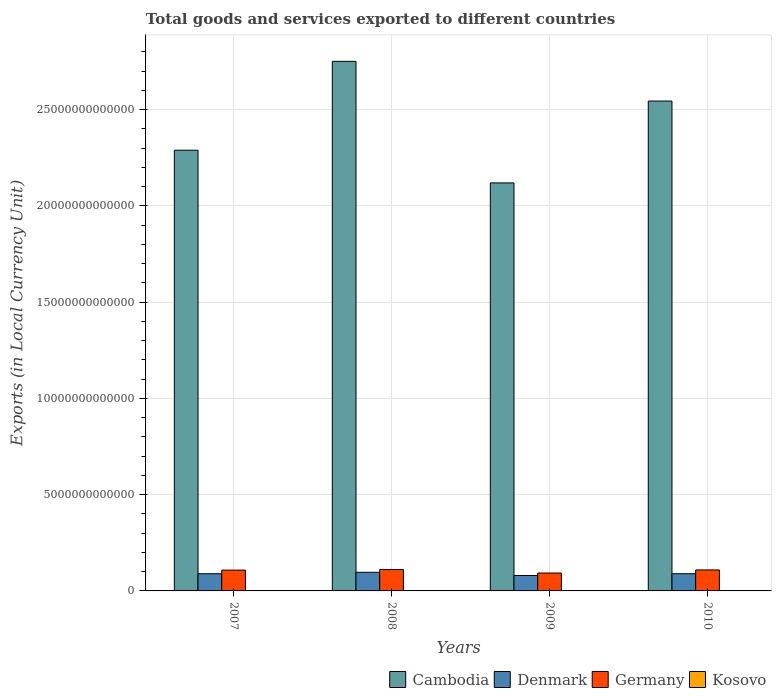How many different coloured bars are there?
Make the answer very short. 4. Are the number of bars per tick equal to the number of legend labels?
Ensure brevity in your answer.  Yes. Are the number of bars on each tick of the X-axis equal?
Offer a very short reply. Yes. How many bars are there on the 4th tick from the right?
Provide a succinct answer. 4. What is the label of the 2nd group of bars from the left?
Provide a short and direct response. 2008. What is the Amount of goods and services exports in Denmark in 2009?
Provide a short and direct response. 8.01e+11. Across all years, what is the maximum Amount of goods and services exports in Denmark?
Give a very brief answer. 9.68e+11. Across all years, what is the minimum Amount of goods and services exports in Denmark?
Ensure brevity in your answer.  8.01e+11. What is the total Amount of goods and services exports in Germany in the graph?
Make the answer very short. 4.21e+12. What is the difference between the Amount of goods and services exports in Cambodia in 2008 and that in 2009?
Keep it short and to the point. 6.31e+12. What is the difference between the Amount of goods and services exports in Cambodia in 2008 and the Amount of goods and services exports in Denmark in 2010?
Ensure brevity in your answer.  2.66e+13. What is the average Amount of goods and services exports in Denmark per year?
Make the answer very short. 8.89e+11. In the year 2008, what is the difference between the Amount of goods and services exports in Denmark and Amount of goods and services exports in Cambodia?
Provide a short and direct response. -2.65e+13. In how many years, is the Amount of goods and services exports in Cambodia greater than 4000000000000 LCU?
Offer a terse response. 4. What is the ratio of the Amount of goods and services exports in Denmark in 2009 to that in 2010?
Your answer should be compact. 0.9. Is the difference between the Amount of goods and services exports in Denmark in 2007 and 2008 greater than the difference between the Amount of goods and services exports in Cambodia in 2007 and 2008?
Give a very brief answer. Yes. What is the difference between the highest and the second highest Amount of goods and services exports in Kosovo?
Your response must be concise. 1.79e+08. What is the difference between the highest and the lowest Amount of goods and services exports in Germany?
Offer a very short reply. 1.83e+11. In how many years, is the Amount of goods and services exports in Denmark greater than the average Amount of goods and services exports in Denmark taken over all years?
Ensure brevity in your answer.  3. Is the sum of the Amount of goods and services exports in Denmark in 2008 and 2010 greater than the maximum Amount of goods and services exports in Germany across all years?
Give a very brief answer. Yes. What does the 1st bar from the left in 2008 represents?
Offer a very short reply. Cambodia. How many bars are there?
Ensure brevity in your answer.  16. How many years are there in the graph?
Make the answer very short. 4. What is the difference between two consecutive major ticks on the Y-axis?
Offer a very short reply. 5.00e+12. Are the values on the major ticks of Y-axis written in scientific E-notation?
Your response must be concise. No. Does the graph contain grids?
Your response must be concise. Yes. How are the legend labels stacked?
Make the answer very short. Horizontal. What is the title of the graph?
Your answer should be compact. Total goods and services exported to different countries. Does "Singapore" appear as one of the legend labels in the graph?
Offer a very short reply. No. What is the label or title of the X-axis?
Keep it short and to the point. Years. What is the label or title of the Y-axis?
Provide a succinct answer. Exports (in Local Currency Unit). What is the Exports (in Local Currency Unit) in Cambodia in 2007?
Provide a short and direct response. 2.29e+13. What is the Exports (in Local Currency Unit) of Denmark in 2007?
Provide a short and direct response. 8.93e+11. What is the Exports (in Local Currency Unit) in Germany in 2007?
Ensure brevity in your answer.  1.08e+12. What is the Exports (in Local Currency Unit) in Kosovo in 2007?
Offer a very short reply. 5.47e+08. What is the Exports (in Local Currency Unit) of Cambodia in 2008?
Provide a short and direct response. 2.75e+13. What is the Exports (in Local Currency Unit) of Denmark in 2008?
Offer a very short reply. 9.68e+11. What is the Exports (in Local Currency Unit) in Germany in 2008?
Ensure brevity in your answer.  1.11e+12. What is the Exports (in Local Currency Unit) in Kosovo in 2008?
Ensure brevity in your answer.  6.08e+08. What is the Exports (in Local Currency Unit) of Cambodia in 2009?
Offer a very short reply. 2.12e+13. What is the Exports (in Local Currency Unit) in Denmark in 2009?
Provide a short and direct response. 8.01e+11. What is the Exports (in Local Currency Unit) in Germany in 2009?
Provide a short and direct response. 9.30e+11. What is the Exports (in Local Currency Unit) in Kosovo in 2009?
Offer a very short reply. 6.94e+08. What is the Exports (in Local Currency Unit) in Cambodia in 2010?
Ensure brevity in your answer.  2.54e+13. What is the Exports (in Local Currency Unit) of Denmark in 2010?
Ensure brevity in your answer.  8.94e+11. What is the Exports (in Local Currency Unit) in Germany in 2010?
Your answer should be compact. 1.09e+12. What is the Exports (in Local Currency Unit) of Kosovo in 2010?
Provide a succinct answer. 8.74e+08. Across all years, what is the maximum Exports (in Local Currency Unit) of Cambodia?
Keep it short and to the point. 2.75e+13. Across all years, what is the maximum Exports (in Local Currency Unit) in Denmark?
Your answer should be very brief. 9.68e+11. Across all years, what is the maximum Exports (in Local Currency Unit) in Germany?
Offer a very short reply. 1.11e+12. Across all years, what is the maximum Exports (in Local Currency Unit) of Kosovo?
Offer a very short reply. 8.74e+08. Across all years, what is the minimum Exports (in Local Currency Unit) of Cambodia?
Your answer should be compact. 2.12e+13. Across all years, what is the minimum Exports (in Local Currency Unit) in Denmark?
Ensure brevity in your answer.  8.01e+11. Across all years, what is the minimum Exports (in Local Currency Unit) in Germany?
Your answer should be compact. 9.30e+11. Across all years, what is the minimum Exports (in Local Currency Unit) of Kosovo?
Your answer should be compact. 5.47e+08. What is the total Exports (in Local Currency Unit) in Cambodia in the graph?
Your answer should be compact. 9.70e+13. What is the total Exports (in Local Currency Unit) of Denmark in the graph?
Make the answer very short. 3.56e+12. What is the total Exports (in Local Currency Unit) of Germany in the graph?
Keep it short and to the point. 4.21e+12. What is the total Exports (in Local Currency Unit) of Kosovo in the graph?
Provide a succinct answer. 2.72e+09. What is the difference between the Exports (in Local Currency Unit) of Cambodia in 2007 and that in 2008?
Give a very brief answer. -4.62e+12. What is the difference between the Exports (in Local Currency Unit) in Denmark in 2007 and that in 2008?
Your response must be concise. -7.51e+1. What is the difference between the Exports (in Local Currency Unit) in Germany in 2007 and that in 2008?
Provide a succinct answer. -3.24e+1. What is the difference between the Exports (in Local Currency Unit) of Kosovo in 2007 and that in 2008?
Your answer should be compact. -6.15e+07. What is the difference between the Exports (in Local Currency Unit) in Cambodia in 2007 and that in 2009?
Offer a terse response. 1.70e+12. What is the difference between the Exports (in Local Currency Unit) of Denmark in 2007 and that in 2009?
Offer a very short reply. 9.20e+1. What is the difference between the Exports (in Local Currency Unit) of Germany in 2007 and that in 2009?
Make the answer very short. 1.51e+11. What is the difference between the Exports (in Local Currency Unit) of Kosovo in 2007 and that in 2009?
Make the answer very short. -1.48e+08. What is the difference between the Exports (in Local Currency Unit) of Cambodia in 2007 and that in 2010?
Ensure brevity in your answer.  -2.55e+12. What is the difference between the Exports (in Local Currency Unit) in Denmark in 2007 and that in 2010?
Provide a short and direct response. -1.41e+09. What is the difference between the Exports (in Local Currency Unit) of Germany in 2007 and that in 2010?
Provide a short and direct response. -9.15e+09. What is the difference between the Exports (in Local Currency Unit) of Kosovo in 2007 and that in 2010?
Offer a very short reply. -3.27e+08. What is the difference between the Exports (in Local Currency Unit) of Cambodia in 2008 and that in 2009?
Your response must be concise. 6.31e+12. What is the difference between the Exports (in Local Currency Unit) in Denmark in 2008 and that in 2009?
Provide a succinct answer. 1.67e+11. What is the difference between the Exports (in Local Currency Unit) of Germany in 2008 and that in 2009?
Make the answer very short. 1.83e+11. What is the difference between the Exports (in Local Currency Unit) in Kosovo in 2008 and that in 2009?
Give a very brief answer. -8.61e+07. What is the difference between the Exports (in Local Currency Unit) of Cambodia in 2008 and that in 2010?
Ensure brevity in your answer.  2.06e+12. What is the difference between the Exports (in Local Currency Unit) in Denmark in 2008 and that in 2010?
Keep it short and to the point. 7.37e+1. What is the difference between the Exports (in Local Currency Unit) in Germany in 2008 and that in 2010?
Offer a terse response. 2.32e+1. What is the difference between the Exports (in Local Currency Unit) in Kosovo in 2008 and that in 2010?
Your answer should be very brief. -2.65e+08. What is the difference between the Exports (in Local Currency Unit) in Cambodia in 2009 and that in 2010?
Your answer should be very brief. -4.25e+12. What is the difference between the Exports (in Local Currency Unit) of Denmark in 2009 and that in 2010?
Your response must be concise. -9.35e+1. What is the difference between the Exports (in Local Currency Unit) in Germany in 2009 and that in 2010?
Keep it short and to the point. -1.60e+11. What is the difference between the Exports (in Local Currency Unit) of Kosovo in 2009 and that in 2010?
Your answer should be compact. -1.79e+08. What is the difference between the Exports (in Local Currency Unit) of Cambodia in 2007 and the Exports (in Local Currency Unit) of Denmark in 2008?
Provide a short and direct response. 2.19e+13. What is the difference between the Exports (in Local Currency Unit) of Cambodia in 2007 and the Exports (in Local Currency Unit) of Germany in 2008?
Keep it short and to the point. 2.18e+13. What is the difference between the Exports (in Local Currency Unit) of Cambodia in 2007 and the Exports (in Local Currency Unit) of Kosovo in 2008?
Your answer should be very brief. 2.29e+13. What is the difference between the Exports (in Local Currency Unit) in Denmark in 2007 and the Exports (in Local Currency Unit) in Germany in 2008?
Keep it short and to the point. -2.20e+11. What is the difference between the Exports (in Local Currency Unit) of Denmark in 2007 and the Exports (in Local Currency Unit) of Kosovo in 2008?
Your answer should be very brief. 8.92e+11. What is the difference between the Exports (in Local Currency Unit) in Germany in 2007 and the Exports (in Local Currency Unit) in Kosovo in 2008?
Keep it short and to the point. 1.08e+12. What is the difference between the Exports (in Local Currency Unit) in Cambodia in 2007 and the Exports (in Local Currency Unit) in Denmark in 2009?
Provide a short and direct response. 2.21e+13. What is the difference between the Exports (in Local Currency Unit) of Cambodia in 2007 and the Exports (in Local Currency Unit) of Germany in 2009?
Keep it short and to the point. 2.20e+13. What is the difference between the Exports (in Local Currency Unit) in Cambodia in 2007 and the Exports (in Local Currency Unit) in Kosovo in 2009?
Keep it short and to the point. 2.29e+13. What is the difference between the Exports (in Local Currency Unit) in Denmark in 2007 and the Exports (in Local Currency Unit) in Germany in 2009?
Ensure brevity in your answer.  -3.72e+1. What is the difference between the Exports (in Local Currency Unit) in Denmark in 2007 and the Exports (in Local Currency Unit) in Kosovo in 2009?
Your answer should be compact. 8.92e+11. What is the difference between the Exports (in Local Currency Unit) in Germany in 2007 and the Exports (in Local Currency Unit) in Kosovo in 2009?
Your answer should be compact. 1.08e+12. What is the difference between the Exports (in Local Currency Unit) in Cambodia in 2007 and the Exports (in Local Currency Unit) in Denmark in 2010?
Give a very brief answer. 2.20e+13. What is the difference between the Exports (in Local Currency Unit) in Cambodia in 2007 and the Exports (in Local Currency Unit) in Germany in 2010?
Provide a short and direct response. 2.18e+13. What is the difference between the Exports (in Local Currency Unit) in Cambodia in 2007 and the Exports (in Local Currency Unit) in Kosovo in 2010?
Offer a terse response. 2.29e+13. What is the difference between the Exports (in Local Currency Unit) in Denmark in 2007 and the Exports (in Local Currency Unit) in Germany in 2010?
Keep it short and to the point. -1.97e+11. What is the difference between the Exports (in Local Currency Unit) in Denmark in 2007 and the Exports (in Local Currency Unit) in Kosovo in 2010?
Your answer should be very brief. 8.92e+11. What is the difference between the Exports (in Local Currency Unit) of Germany in 2007 and the Exports (in Local Currency Unit) of Kosovo in 2010?
Your answer should be compact. 1.08e+12. What is the difference between the Exports (in Local Currency Unit) of Cambodia in 2008 and the Exports (in Local Currency Unit) of Denmark in 2009?
Your answer should be compact. 2.67e+13. What is the difference between the Exports (in Local Currency Unit) of Cambodia in 2008 and the Exports (in Local Currency Unit) of Germany in 2009?
Offer a terse response. 2.66e+13. What is the difference between the Exports (in Local Currency Unit) in Cambodia in 2008 and the Exports (in Local Currency Unit) in Kosovo in 2009?
Your answer should be compact. 2.75e+13. What is the difference between the Exports (in Local Currency Unit) of Denmark in 2008 and the Exports (in Local Currency Unit) of Germany in 2009?
Provide a short and direct response. 3.79e+1. What is the difference between the Exports (in Local Currency Unit) in Denmark in 2008 and the Exports (in Local Currency Unit) in Kosovo in 2009?
Your answer should be compact. 9.67e+11. What is the difference between the Exports (in Local Currency Unit) in Germany in 2008 and the Exports (in Local Currency Unit) in Kosovo in 2009?
Your response must be concise. 1.11e+12. What is the difference between the Exports (in Local Currency Unit) of Cambodia in 2008 and the Exports (in Local Currency Unit) of Denmark in 2010?
Make the answer very short. 2.66e+13. What is the difference between the Exports (in Local Currency Unit) of Cambodia in 2008 and the Exports (in Local Currency Unit) of Germany in 2010?
Your response must be concise. 2.64e+13. What is the difference between the Exports (in Local Currency Unit) of Cambodia in 2008 and the Exports (in Local Currency Unit) of Kosovo in 2010?
Your response must be concise. 2.75e+13. What is the difference between the Exports (in Local Currency Unit) in Denmark in 2008 and the Exports (in Local Currency Unit) in Germany in 2010?
Give a very brief answer. -1.22e+11. What is the difference between the Exports (in Local Currency Unit) of Denmark in 2008 and the Exports (in Local Currency Unit) of Kosovo in 2010?
Provide a short and direct response. 9.67e+11. What is the difference between the Exports (in Local Currency Unit) of Germany in 2008 and the Exports (in Local Currency Unit) of Kosovo in 2010?
Offer a terse response. 1.11e+12. What is the difference between the Exports (in Local Currency Unit) in Cambodia in 2009 and the Exports (in Local Currency Unit) in Denmark in 2010?
Offer a very short reply. 2.03e+13. What is the difference between the Exports (in Local Currency Unit) in Cambodia in 2009 and the Exports (in Local Currency Unit) in Germany in 2010?
Offer a terse response. 2.01e+13. What is the difference between the Exports (in Local Currency Unit) of Cambodia in 2009 and the Exports (in Local Currency Unit) of Kosovo in 2010?
Your response must be concise. 2.12e+13. What is the difference between the Exports (in Local Currency Unit) of Denmark in 2009 and the Exports (in Local Currency Unit) of Germany in 2010?
Provide a short and direct response. -2.89e+11. What is the difference between the Exports (in Local Currency Unit) of Denmark in 2009 and the Exports (in Local Currency Unit) of Kosovo in 2010?
Keep it short and to the point. 8.00e+11. What is the difference between the Exports (in Local Currency Unit) in Germany in 2009 and the Exports (in Local Currency Unit) in Kosovo in 2010?
Offer a terse response. 9.29e+11. What is the average Exports (in Local Currency Unit) in Cambodia per year?
Your answer should be very brief. 2.43e+13. What is the average Exports (in Local Currency Unit) in Denmark per year?
Your response must be concise. 8.89e+11. What is the average Exports (in Local Currency Unit) of Germany per year?
Offer a very short reply. 1.05e+12. What is the average Exports (in Local Currency Unit) of Kosovo per year?
Your answer should be very brief. 6.81e+08. In the year 2007, what is the difference between the Exports (in Local Currency Unit) in Cambodia and Exports (in Local Currency Unit) in Denmark?
Give a very brief answer. 2.20e+13. In the year 2007, what is the difference between the Exports (in Local Currency Unit) in Cambodia and Exports (in Local Currency Unit) in Germany?
Offer a very short reply. 2.18e+13. In the year 2007, what is the difference between the Exports (in Local Currency Unit) of Cambodia and Exports (in Local Currency Unit) of Kosovo?
Offer a terse response. 2.29e+13. In the year 2007, what is the difference between the Exports (in Local Currency Unit) of Denmark and Exports (in Local Currency Unit) of Germany?
Your response must be concise. -1.88e+11. In the year 2007, what is the difference between the Exports (in Local Currency Unit) in Denmark and Exports (in Local Currency Unit) in Kosovo?
Provide a succinct answer. 8.92e+11. In the year 2007, what is the difference between the Exports (in Local Currency Unit) of Germany and Exports (in Local Currency Unit) of Kosovo?
Provide a short and direct response. 1.08e+12. In the year 2008, what is the difference between the Exports (in Local Currency Unit) of Cambodia and Exports (in Local Currency Unit) of Denmark?
Keep it short and to the point. 2.65e+13. In the year 2008, what is the difference between the Exports (in Local Currency Unit) in Cambodia and Exports (in Local Currency Unit) in Germany?
Keep it short and to the point. 2.64e+13. In the year 2008, what is the difference between the Exports (in Local Currency Unit) of Cambodia and Exports (in Local Currency Unit) of Kosovo?
Your answer should be compact. 2.75e+13. In the year 2008, what is the difference between the Exports (in Local Currency Unit) of Denmark and Exports (in Local Currency Unit) of Germany?
Ensure brevity in your answer.  -1.45e+11. In the year 2008, what is the difference between the Exports (in Local Currency Unit) of Denmark and Exports (in Local Currency Unit) of Kosovo?
Ensure brevity in your answer.  9.67e+11. In the year 2008, what is the difference between the Exports (in Local Currency Unit) of Germany and Exports (in Local Currency Unit) of Kosovo?
Give a very brief answer. 1.11e+12. In the year 2009, what is the difference between the Exports (in Local Currency Unit) in Cambodia and Exports (in Local Currency Unit) in Denmark?
Keep it short and to the point. 2.04e+13. In the year 2009, what is the difference between the Exports (in Local Currency Unit) in Cambodia and Exports (in Local Currency Unit) in Germany?
Offer a terse response. 2.03e+13. In the year 2009, what is the difference between the Exports (in Local Currency Unit) of Cambodia and Exports (in Local Currency Unit) of Kosovo?
Provide a succinct answer. 2.12e+13. In the year 2009, what is the difference between the Exports (in Local Currency Unit) of Denmark and Exports (in Local Currency Unit) of Germany?
Your answer should be compact. -1.29e+11. In the year 2009, what is the difference between the Exports (in Local Currency Unit) of Denmark and Exports (in Local Currency Unit) of Kosovo?
Offer a very short reply. 8.00e+11. In the year 2009, what is the difference between the Exports (in Local Currency Unit) of Germany and Exports (in Local Currency Unit) of Kosovo?
Provide a short and direct response. 9.29e+11. In the year 2010, what is the difference between the Exports (in Local Currency Unit) of Cambodia and Exports (in Local Currency Unit) of Denmark?
Ensure brevity in your answer.  2.46e+13. In the year 2010, what is the difference between the Exports (in Local Currency Unit) of Cambodia and Exports (in Local Currency Unit) of Germany?
Keep it short and to the point. 2.44e+13. In the year 2010, what is the difference between the Exports (in Local Currency Unit) of Cambodia and Exports (in Local Currency Unit) of Kosovo?
Keep it short and to the point. 2.54e+13. In the year 2010, what is the difference between the Exports (in Local Currency Unit) in Denmark and Exports (in Local Currency Unit) in Germany?
Provide a short and direct response. -1.96e+11. In the year 2010, what is the difference between the Exports (in Local Currency Unit) in Denmark and Exports (in Local Currency Unit) in Kosovo?
Your answer should be very brief. 8.93e+11. In the year 2010, what is the difference between the Exports (in Local Currency Unit) of Germany and Exports (in Local Currency Unit) of Kosovo?
Offer a very short reply. 1.09e+12. What is the ratio of the Exports (in Local Currency Unit) in Cambodia in 2007 to that in 2008?
Your answer should be very brief. 0.83. What is the ratio of the Exports (in Local Currency Unit) of Denmark in 2007 to that in 2008?
Your answer should be very brief. 0.92. What is the ratio of the Exports (in Local Currency Unit) of Germany in 2007 to that in 2008?
Your answer should be compact. 0.97. What is the ratio of the Exports (in Local Currency Unit) of Kosovo in 2007 to that in 2008?
Offer a terse response. 0.9. What is the ratio of the Exports (in Local Currency Unit) in Cambodia in 2007 to that in 2009?
Ensure brevity in your answer.  1.08. What is the ratio of the Exports (in Local Currency Unit) in Denmark in 2007 to that in 2009?
Provide a succinct answer. 1.11. What is the ratio of the Exports (in Local Currency Unit) in Germany in 2007 to that in 2009?
Offer a very short reply. 1.16. What is the ratio of the Exports (in Local Currency Unit) in Kosovo in 2007 to that in 2009?
Provide a short and direct response. 0.79. What is the ratio of the Exports (in Local Currency Unit) in Cambodia in 2007 to that in 2010?
Your answer should be compact. 0.9. What is the ratio of the Exports (in Local Currency Unit) in Denmark in 2007 to that in 2010?
Provide a succinct answer. 1. What is the ratio of the Exports (in Local Currency Unit) in Germany in 2007 to that in 2010?
Your answer should be very brief. 0.99. What is the ratio of the Exports (in Local Currency Unit) in Kosovo in 2007 to that in 2010?
Offer a terse response. 0.63. What is the ratio of the Exports (in Local Currency Unit) of Cambodia in 2008 to that in 2009?
Your answer should be compact. 1.3. What is the ratio of the Exports (in Local Currency Unit) in Denmark in 2008 to that in 2009?
Your answer should be very brief. 1.21. What is the ratio of the Exports (in Local Currency Unit) in Germany in 2008 to that in 2009?
Provide a succinct answer. 1.2. What is the ratio of the Exports (in Local Currency Unit) of Kosovo in 2008 to that in 2009?
Your answer should be very brief. 0.88. What is the ratio of the Exports (in Local Currency Unit) of Cambodia in 2008 to that in 2010?
Provide a short and direct response. 1.08. What is the ratio of the Exports (in Local Currency Unit) of Denmark in 2008 to that in 2010?
Your response must be concise. 1.08. What is the ratio of the Exports (in Local Currency Unit) in Germany in 2008 to that in 2010?
Your answer should be very brief. 1.02. What is the ratio of the Exports (in Local Currency Unit) in Kosovo in 2008 to that in 2010?
Your answer should be compact. 0.7. What is the ratio of the Exports (in Local Currency Unit) in Cambodia in 2009 to that in 2010?
Keep it short and to the point. 0.83. What is the ratio of the Exports (in Local Currency Unit) in Denmark in 2009 to that in 2010?
Make the answer very short. 0.9. What is the ratio of the Exports (in Local Currency Unit) in Germany in 2009 to that in 2010?
Make the answer very short. 0.85. What is the ratio of the Exports (in Local Currency Unit) of Kosovo in 2009 to that in 2010?
Keep it short and to the point. 0.79. What is the difference between the highest and the second highest Exports (in Local Currency Unit) in Cambodia?
Your response must be concise. 2.06e+12. What is the difference between the highest and the second highest Exports (in Local Currency Unit) in Denmark?
Your answer should be compact. 7.37e+1. What is the difference between the highest and the second highest Exports (in Local Currency Unit) in Germany?
Give a very brief answer. 2.32e+1. What is the difference between the highest and the second highest Exports (in Local Currency Unit) in Kosovo?
Give a very brief answer. 1.79e+08. What is the difference between the highest and the lowest Exports (in Local Currency Unit) in Cambodia?
Make the answer very short. 6.31e+12. What is the difference between the highest and the lowest Exports (in Local Currency Unit) in Denmark?
Your answer should be compact. 1.67e+11. What is the difference between the highest and the lowest Exports (in Local Currency Unit) of Germany?
Provide a short and direct response. 1.83e+11. What is the difference between the highest and the lowest Exports (in Local Currency Unit) of Kosovo?
Offer a terse response. 3.27e+08. 